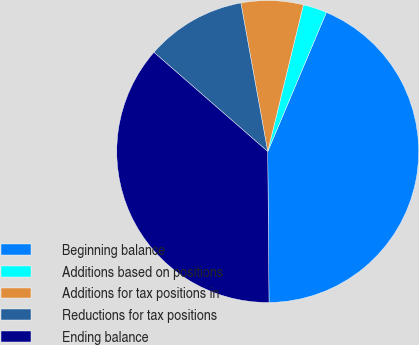<chart> <loc_0><loc_0><loc_500><loc_500><pie_chart><fcel>Beginning balance<fcel>Additions based on positions<fcel>Additions for tax positions in<fcel>Reductions for tax positions<fcel>Ending balance<nl><fcel>43.51%<fcel>2.55%<fcel>6.64%<fcel>10.74%<fcel>36.55%<nl></chart> 